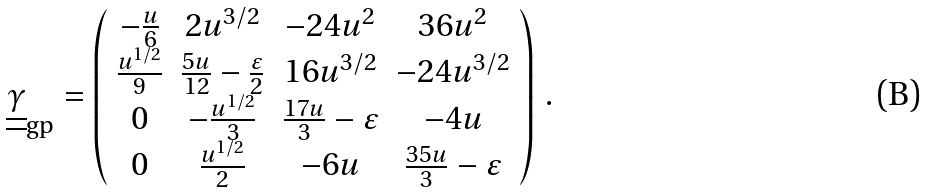Convert formula to latex. <formula><loc_0><loc_0><loc_500><loc_500>\underline { \underline { \gamma } } _ { \text {gp} } = \left ( \begin{array} { c c c c } - \frac { u } { 6 } & 2 u ^ { 3 / 2 } & - 2 4 u ^ { 2 } & 3 6 u ^ { 2 } \\ \frac { u ^ { 1 / 2 } } { 9 } & \frac { 5 u } { 1 2 } - \frac { \varepsilon } { 2 } & 1 6 u ^ { 3 / 2 } & - 2 4 u ^ { 3 / 2 } \\ 0 & - \frac { u ^ { 1 / 2 } } { 3 } & \frac { 1 7 u } { 3 } - \varepsilon & - 4 u \\ 0 & \frac { u ^ { 1 / 2 } } { 2 } & - 6 u & \frac { 3 5 u } { 3 } - \varepsilon \end{array} \right ) \, .</formula> 